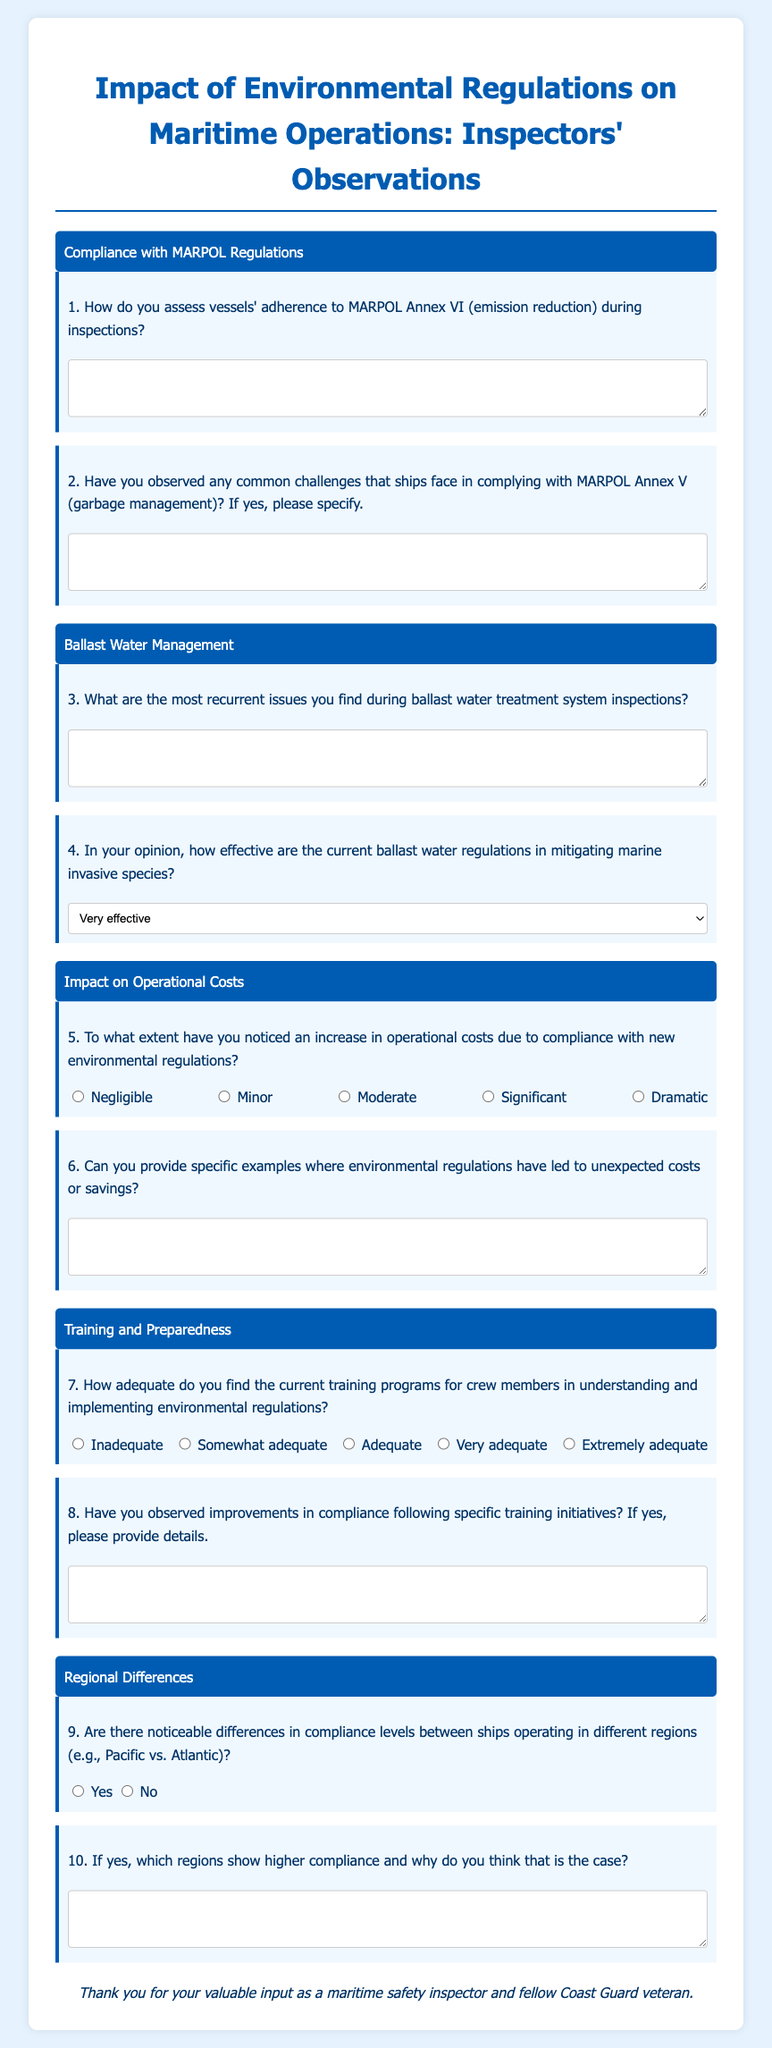What is the title of the questionnaire? The title of the questionnaire is prominently displayed at the top of the document.
Answer: Impact of Environmental Regulations on Maritime Operations: Inspectors' Observations How many topics are covered in the document? The document includes specific sections that denote different topics related to maritime operations.
Answer: Five What is the first topic mentioned in the questionnaire? The first topic is clearly labeled at the beginning of the respective section in the document.
Answer: Compliance with MARPOL Regulations What type of scale is used for assessing the impact on operational costs? The document includes a specific format for responding to questions about operational costs.
Answer: Rating scale What is the purpose of the question regarding ballast water regulations? The document highlights how certain regulations are evaluated in terms of their effectiveness.
Answer: To assess their effectiveness in mitigating marine invasive species What aspect of training does question 7 address? The question focuses on the adequacy of training programs for a specific group involved in maritime operations.
Answer: Crew members What does question 9 inquire about regarding ships? The question is aimed at understanding compliance variations between different operational areas.
Answer: Compliance levels between ships operating in different regions What type of input is sought from maritime safety inspectors? The document encourages specific types of feedback from inspectors on observed practices and regulations.
Answer: Valuable input 